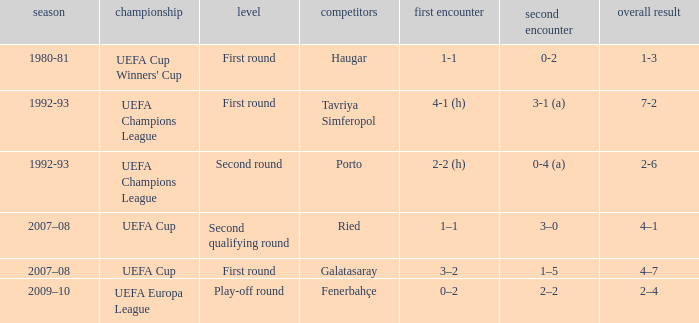What is the total number of 2nd leg where aggregate is 7-2 1.0. 